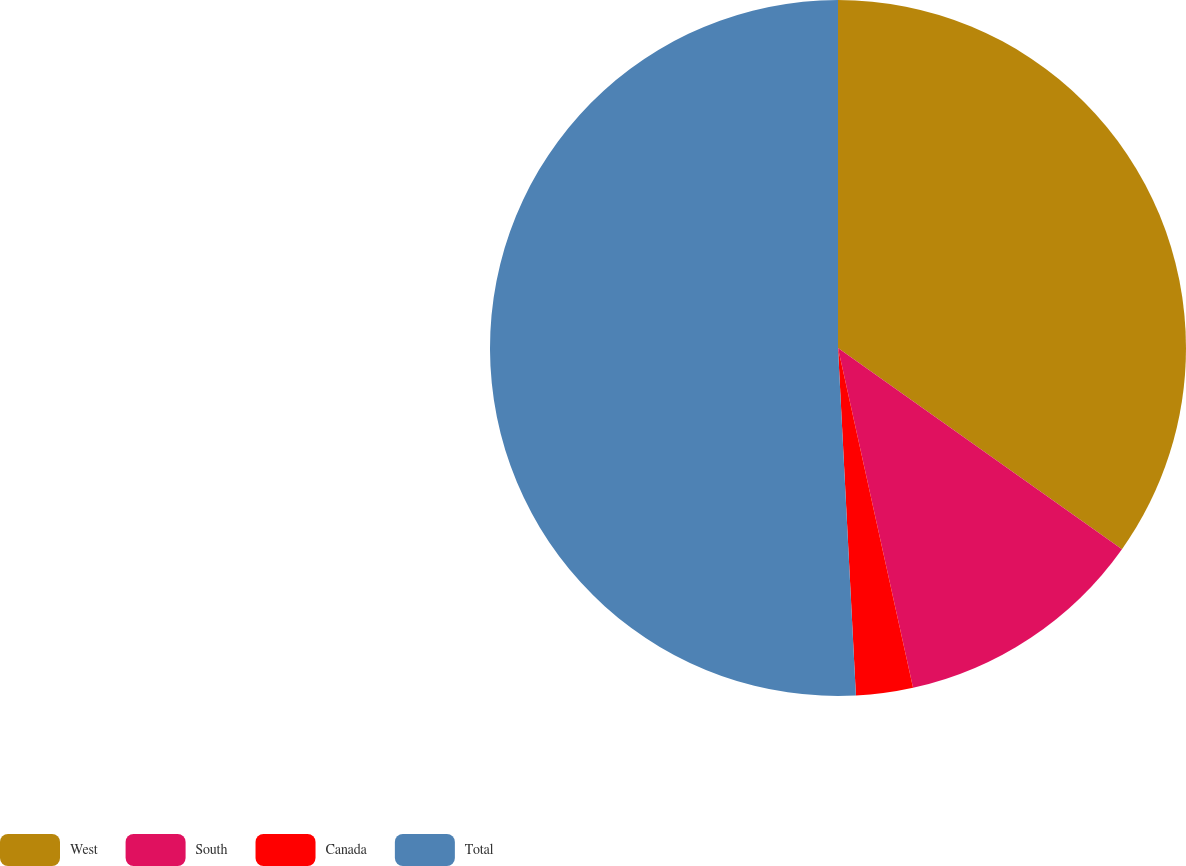Convert chart to OTSL. <chart><loc_0><loc_0><loc_500><loc_500><pie_chart><fcel>West<fcel>South<fcel>Canada<fcel>Total<nl><fcel>34.81%<fcel>11.73%<fcel>2.64%<fcel>50.82%<nl></chart> 